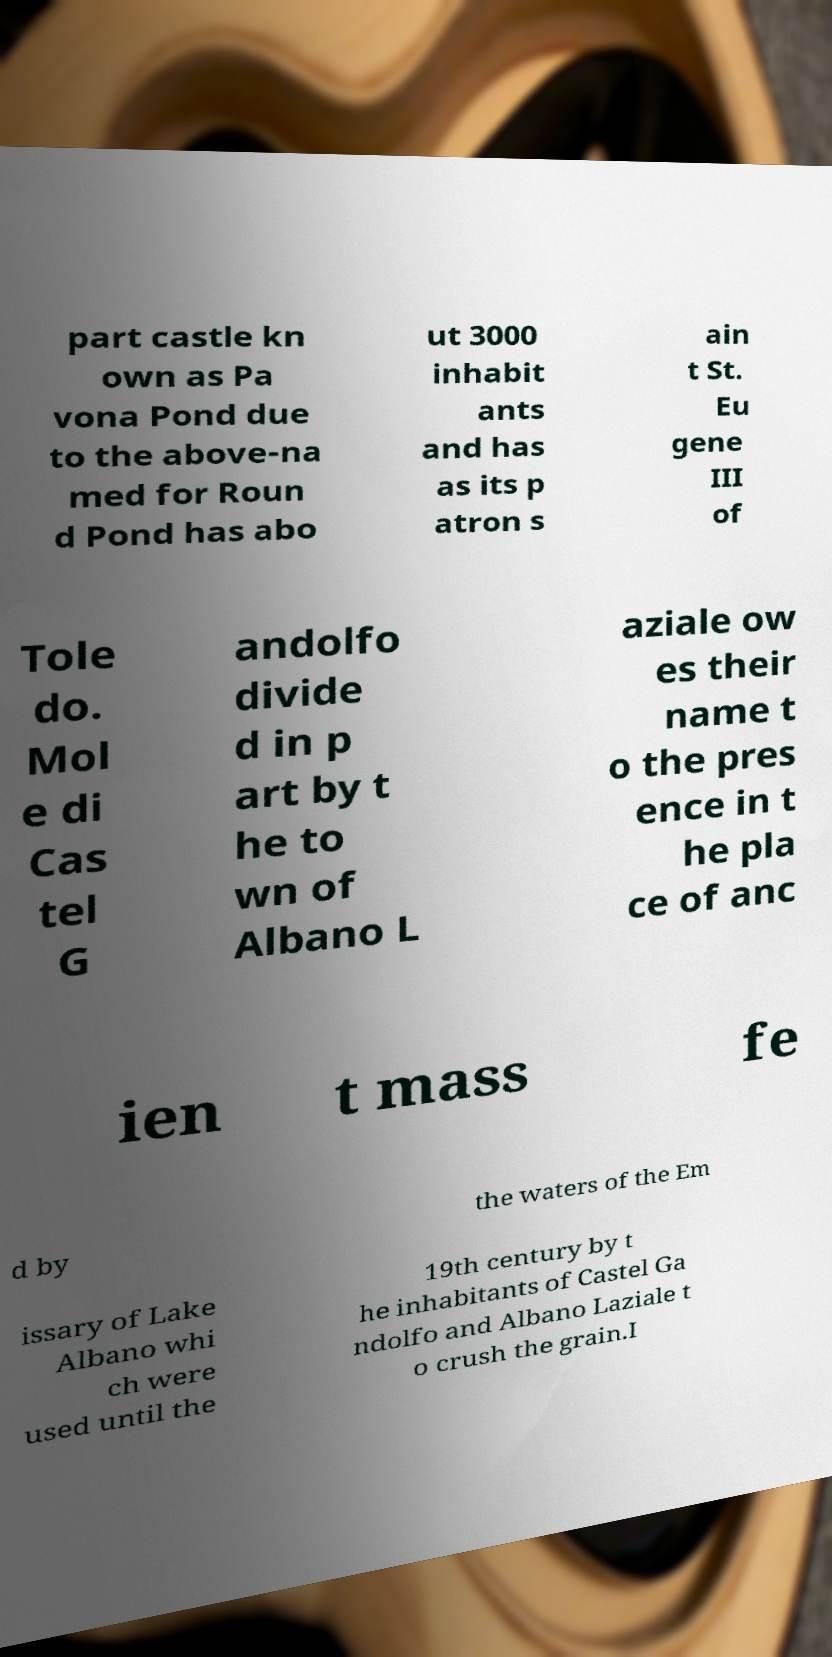What messages or text are displayed in this image? I need them in a readable, typed format. part castle kn own as Pa vona Pond due to the above-na med for Roun d Pond has abo ut 3000 inhabit ants and has as its p atron s ain t St. Eu gene III of Tole do. Mol e di Cas tel G andolfo divide d in p art by t he to wn of Albano L aziale ow es their name t o the pres ence in t he pla ce of anc ien t mass fe d by the waters of the Em issary of Lake Albano whi ch were used until the 19th century by t he inhabitants of Castel Ga ndolfo and Albano Laziale t o crush the grain.I 